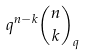<formula> <loc_0><loc_0><loc_500><loc_500>q ^ { n - k } { \binom { n } { k } } _ { q }</formula> 